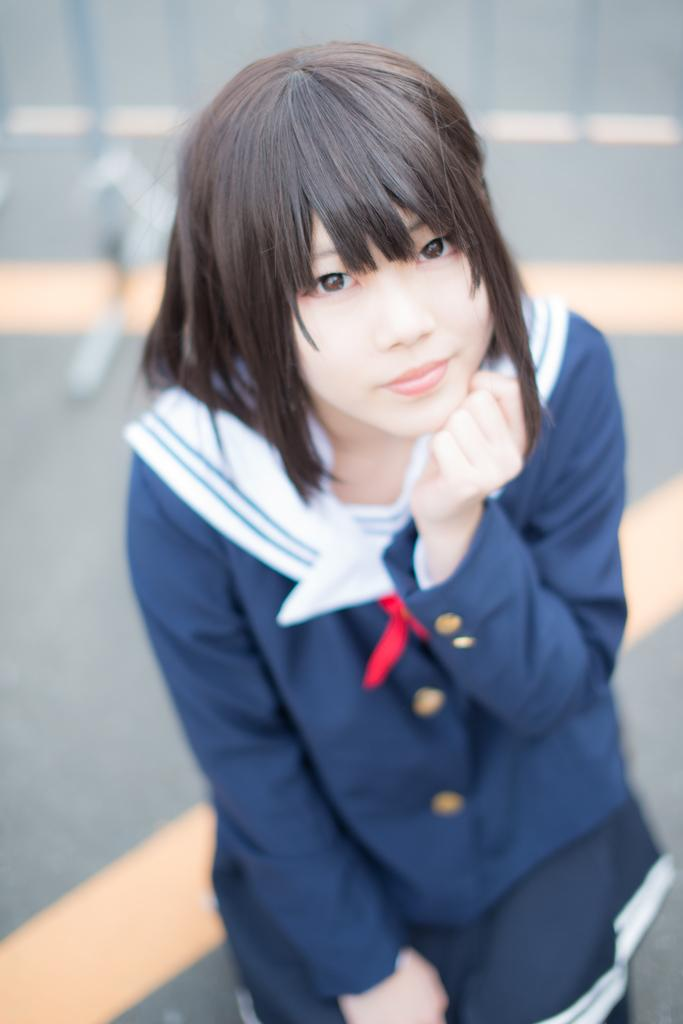What is the main subject of the image? The main subject of the image is a woman. What is the woman wearing in the image? The woman is wearing a blue jacket and shorts. Where is the woman located in the image? The woman is standing on a road. What type of secretary is running on the earth in the image? There is no secretary or running depicted in the image; it features a woman standing on a road. 